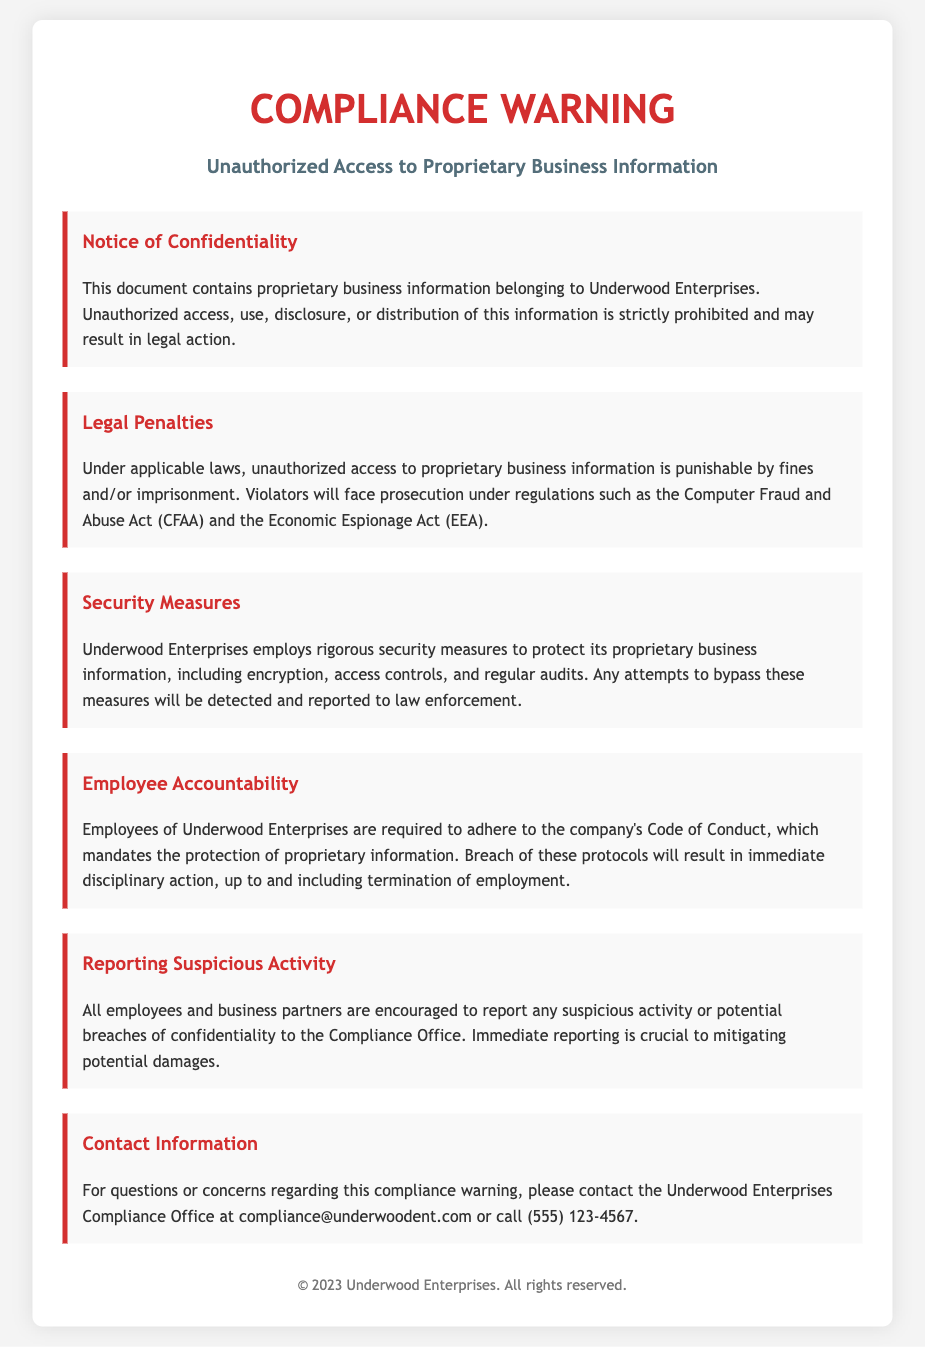What is the title of the document? The title of the document is mentioned in the HTML title tag and at the top header section as a prominent heading.
Answer: Compliance Warning - Underwood Enterprises What is prohibited under the notice of confidentiality? The notice of confidentiality specifies what actions are strictly prohibited regarding proprietary business information.
Answer: Unauthorized access, use, disclosure, or distribution Which act is mentioned in relation to legal penalties? The legal penalties section references a specific act related to unauthorized access to proprietary business information.
Answer: Computer Fraud and Abuse Act (CFAA) What consequences may violators face? The document states consequences that violators may encounter under applicable laws concerning unauthorized access.
Answer: Fines and/or imprisonment What is required from employees concerning proprietary information? The employee accountability section outlines what employees are mandated to comply with regarding proprietary information.
Answer: Adhere to the company's Code of Conduct What should be reported to the Compliance Office? The reporting suspicious activity section highlights what type of incidents should be reported immediately for damage mitigation.
Answer: Suspicious activity or potential breaches of confidentiality How can one contact the Compliance Office? The contact information section provides ways to reach the Compliance Office for questions or concerns.
Answer: compliance@underwoodent.com or call (555) 123-4567 What security measures are employed by Underwood Enterprises? The security measures section lists types of protective measures that Underwood Enterprises uses to safeguard proprietary information.
Answer: Encryption, access controls, and regular audits 